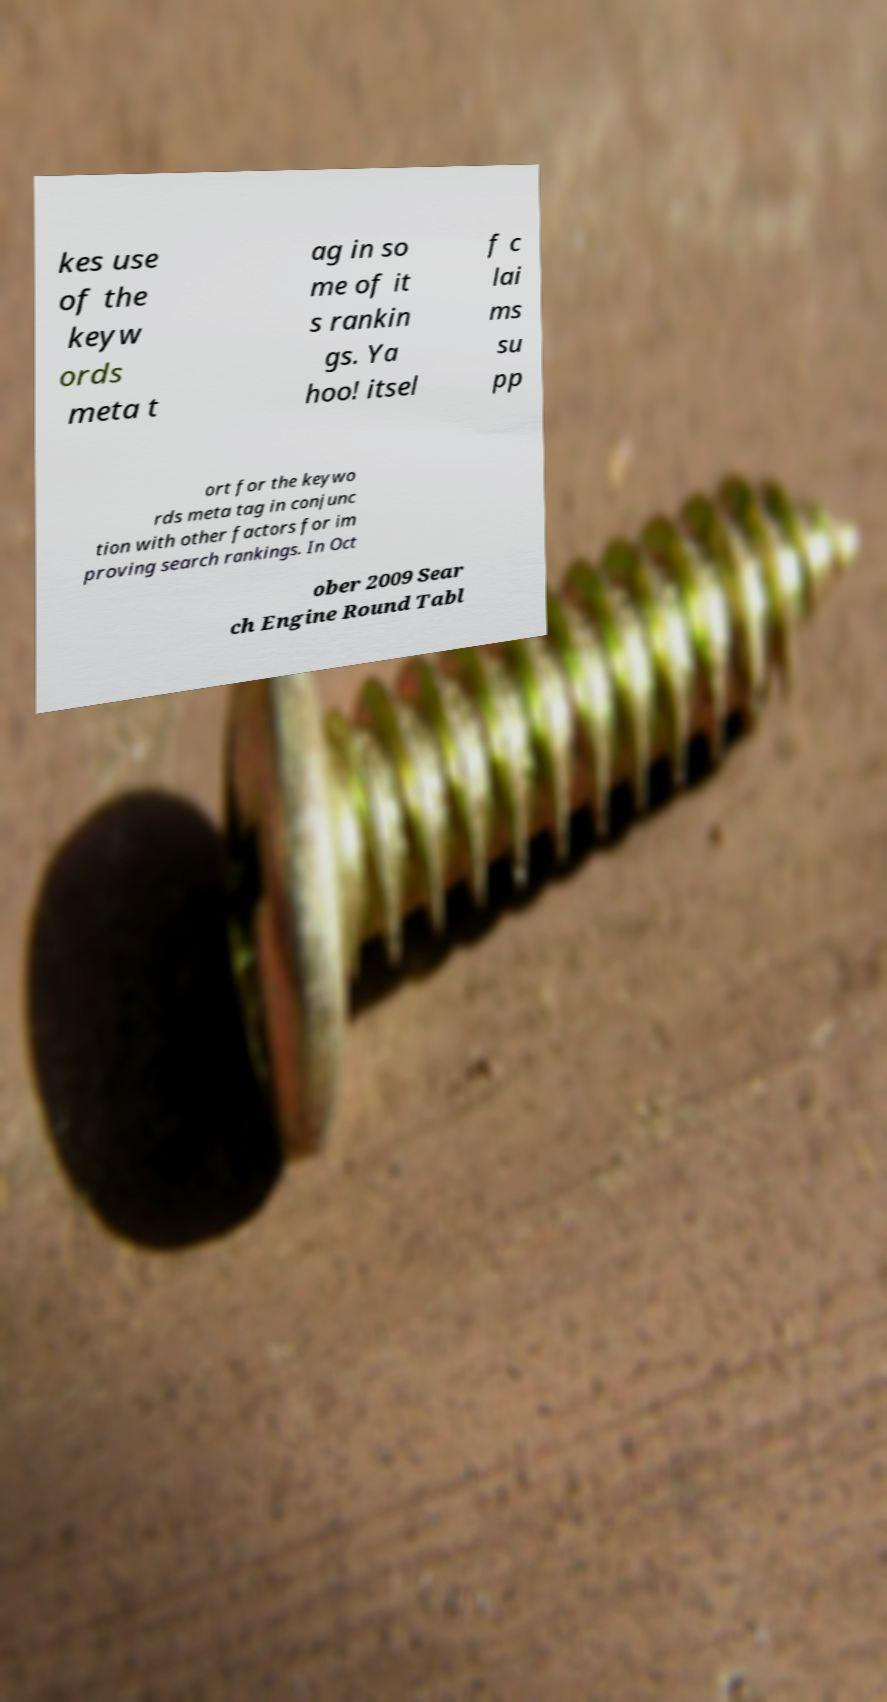Can you accurately transcribe the text from the provided image for me? kes use of the keyw ords meta t ag in so me of it s rankin gs. Ya hoo! itsel f c lai ms su pp ort for the keywo rds meta tag in conjunc tion with other factors for im proving search rankings. In Oct ober 2009 Sear ch Engine Round Tabl 